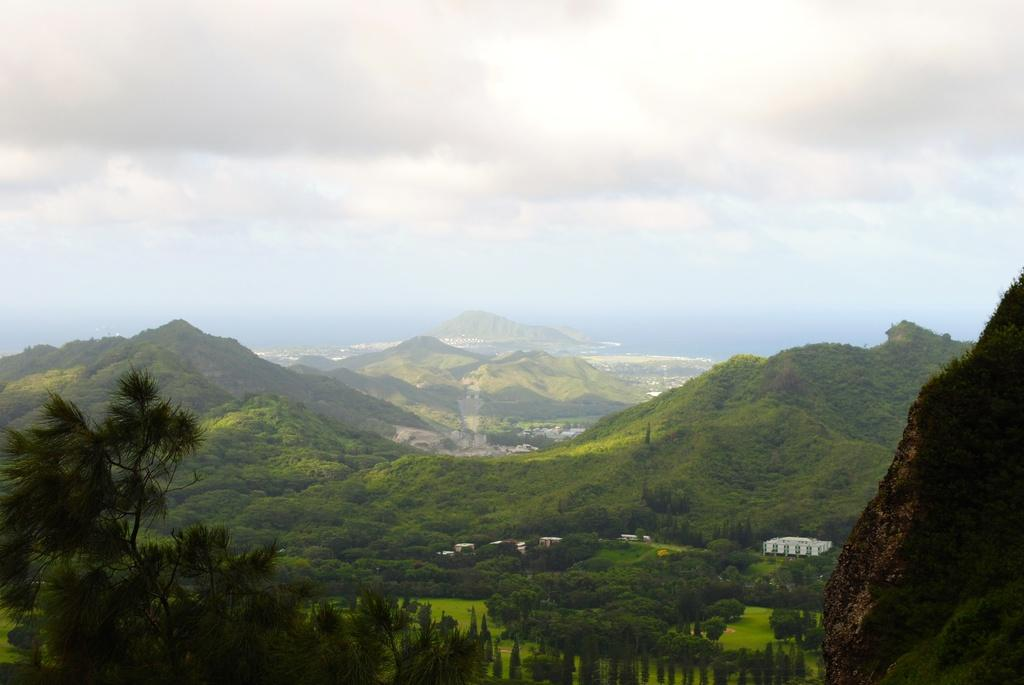What type of natural landscape is depicted in the image? There are hills in the image. What other elements can be seen in the image? There are trees and buildings in the image. What is visible in the background of the image? The sky is visible in the background of the image. How would you describe the weather in the image? The sky is cloudy, which suggests a potentially overcast or rainy day. What type of lamp is hanging from the head of the person in the image? There is no person or lamp present in the image; it features hills, trees, buildings, and a cloudy sky. 